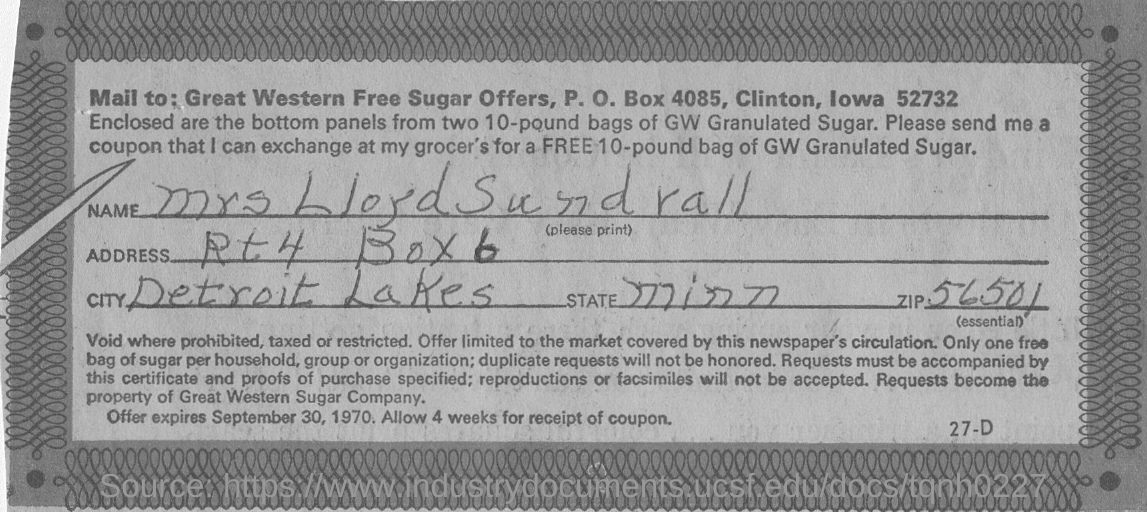What is the name written ?
Offer a terse response. Mrs LloydSundrall. 